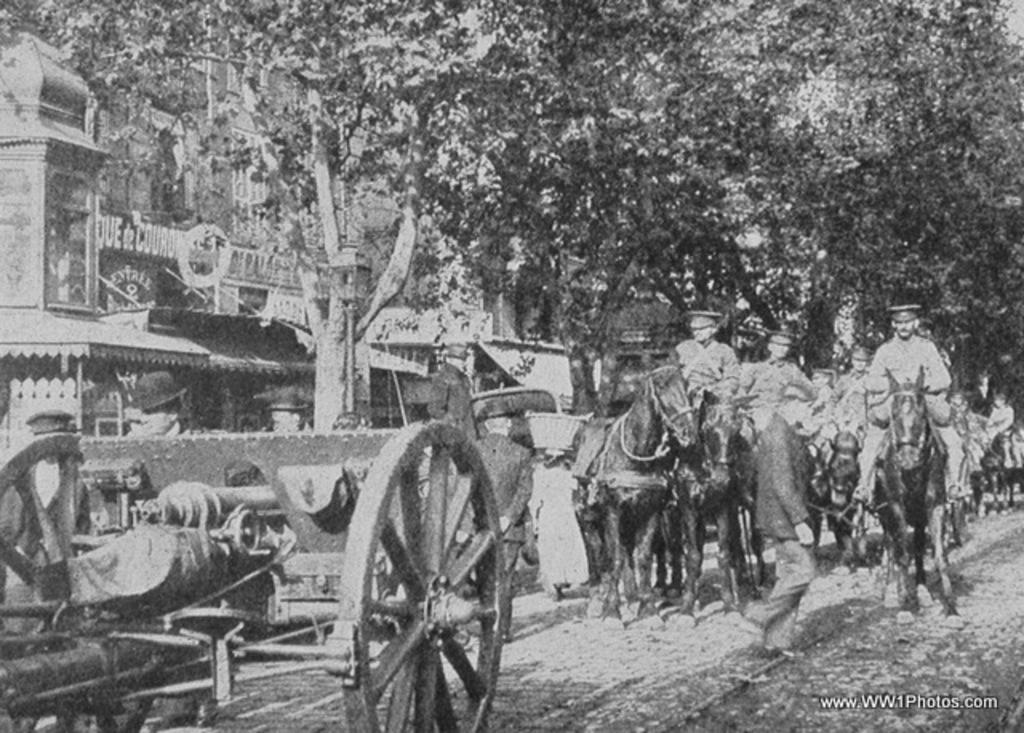What is the color scheme of the image? The image is black and white. What are the people in the image doing? The people are riding on horses. What type of vegetation can be seen in the image? There are trees in the image. What is the purpose of the cart in the image? The cart is likely used for transporting goods or people. What type of structure is visible in the image? There is a building in the image. Can you tell me how many elbows are visible in the image? There is no mention of elbows in the provided facts, so it is impossible to determine how many elbows are visible in the image. 